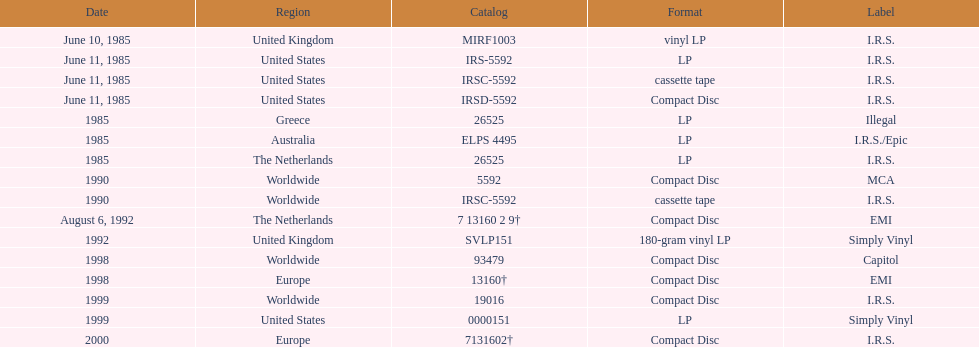How many times was the album released? 13. Give me the full table as a dictionary. {'header': ['Date', 'Region', 'Catalog', 'Format', 'Label'], 'rows': [['June 10, 1985', 'United Kingdom', 'MIRF1003', 'vinyl LP', 'I.R.S.'], ['June 11, 1985', 'United States', 'IRS-5592', 'LP', 'I.R.S.'], ['June 11, 1985', 'United States', 'IRSC-5592', 'cassette tape', 'I.R.S.'], ['June 11, 1985', 'United States', 'IRSD-5592', 'Compact Disc', 'I.R.S.'], ['1985', 'Greece', '26525', 'LP', 'Illegal'], ['1985', 'Australia', 'ELPS 4495', 'LP', 'I.R.S./Epic'], ['1985', 'The Netherlands', '26525', 'LP', 'I.R.S.'], ['1990', 'Worldwide', '5592', 'Compact Disc', 'MCA'], ['1990', 'Worldwide', 'IRSC-5592', 'cassette tape', 'I.R.S.'], ['August 6, 1992', 'The Netherlands', '7 13160 2 9†', 'Compact Disc', 'EMI'], ['1992', 'United Kingdom', 'SVLP151', '180-gram vinyl LP', 'Simply Vinyl'], ['1998', 'Worldwide', '93479', 'Compact Disc', 'Capitol'], ['1998', 'Europe', '13160†', 'Compact Disc', 'EMI'], ['1999', 'Worldwide', '19016', 'Compact Disc', 'I.R.S.'], ['1999', 'United States', '0000151', 'LP', 'Simply Vinyl'], ['2000', 'Europe', '7131602†', 'Compact Disc', 'I.R.S.']]} 